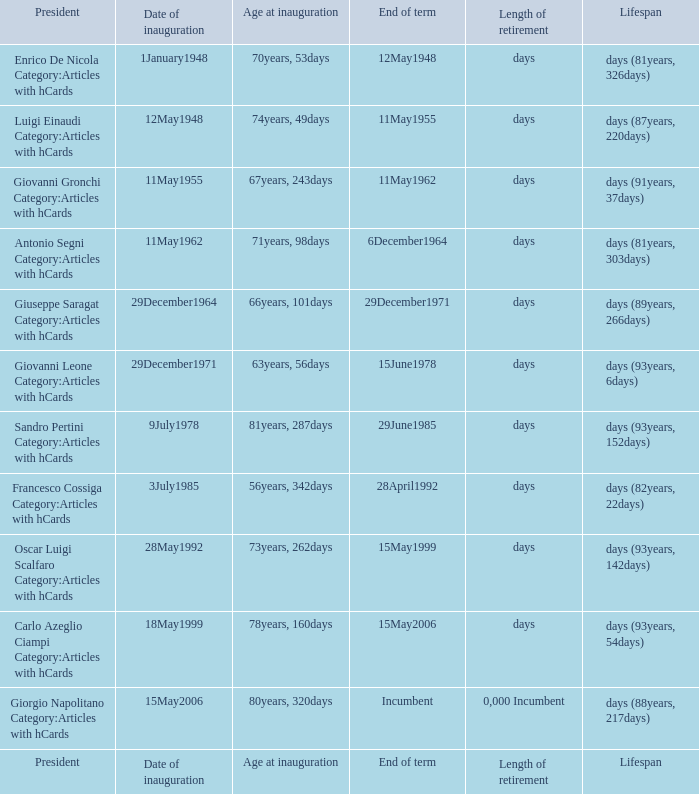What is the inauguration day of the president who was 73 years, 262 days old at the time of inauguration? 28May1992. 